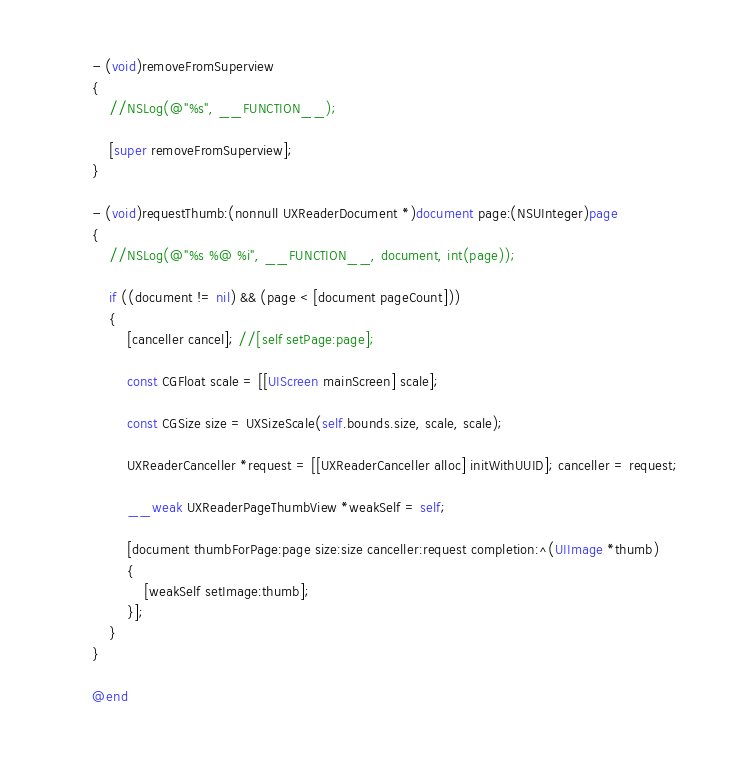<code> <loc_0><loc_0><loc_500><loc_500><_ObjectiveC_>- (void)removeFromSuperview
{
	//NSLog(@"%s", __FUNCTION__);

	[super removeFromSuperview];
}

- (void)requestThumb:(nonnull UXReaderDocument *)document page:(NSUInteger)page
{
	//NSLog(@"%s %@ %i", __FUNCTION__, document, int(page));

	if ((document != nil) && (page < [document pageCount]))
	{
		[canceller cancel]; //[self setPage:page];

		const CGFloat scale = [[UIScreen mainScreen] scale];

		const CGSize size = UXSizeScale(self.bounds.size, scale, scale);

		UXReaderCanceller *request = [[UXReaderCanceller alloc] initWithUUID]; canceller = request;

		__weak UXReaderPageThumbView *weakSelf = self;

		[document thumbForPage:page size:size canceller:request completion:^(UIImage *thumb)
		{
			[weakSelf setImage:thumb];
		}];
	}
}

@end
</code> 